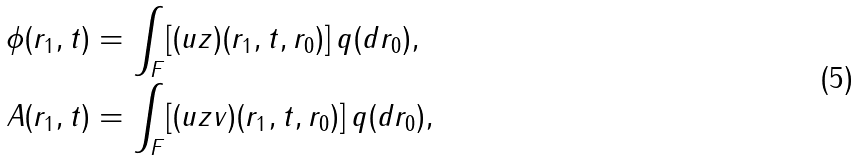Convert formula to latex. <formula><loc_0><loc_0><loc_500><loc_500>\phi ( r _ { 1 } , t ) & = \int _ { F } [ ( u z ) ( r _ { 1 } , t , r _ { 0 } ) ] \, q ( d r _ { 0 } ) , \\ A ( r _ { 1 } , t ) & = \int _ { F } [ ( u z v ) ( r _ { 1 } , t , r _ { 0 } ) ] \, q ( d r _ { 0 } ) , \\</formula> 